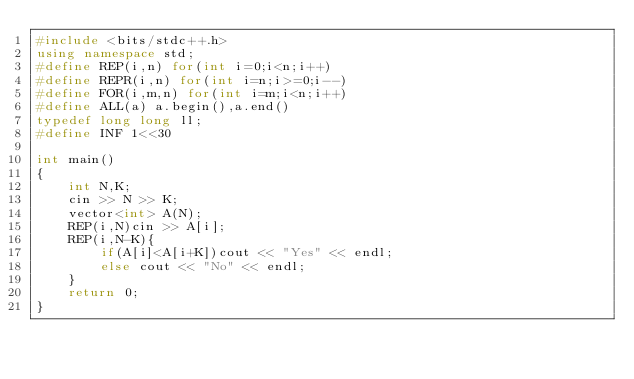<code> <loc_0><loc_0><loc_500><loc_500><_C++_>#include <bits/stdc++.h>
using namespace std;
#define REP(i,n) for(int i=0;i<n;i++)
#define REPR(i,n) for(int i=n;i>=0;i--)
#define FOR(i,m,n) for(int i=m;i<n;i++)
#define ALL(a) a.begin(),a.end()
typedef long long ll;
#define INF 1<<30

int main()
{
    int N,K;
    cin >> N >> K;
    vector<int> A(N);
    REP(i,N)cin >> A[i];
    REP(i,N-K){
        if(A[i]<A[i+K])cout << "Yes" << endl;
        else cout << "No" << endl;
    }
    return 0;
}</code> 